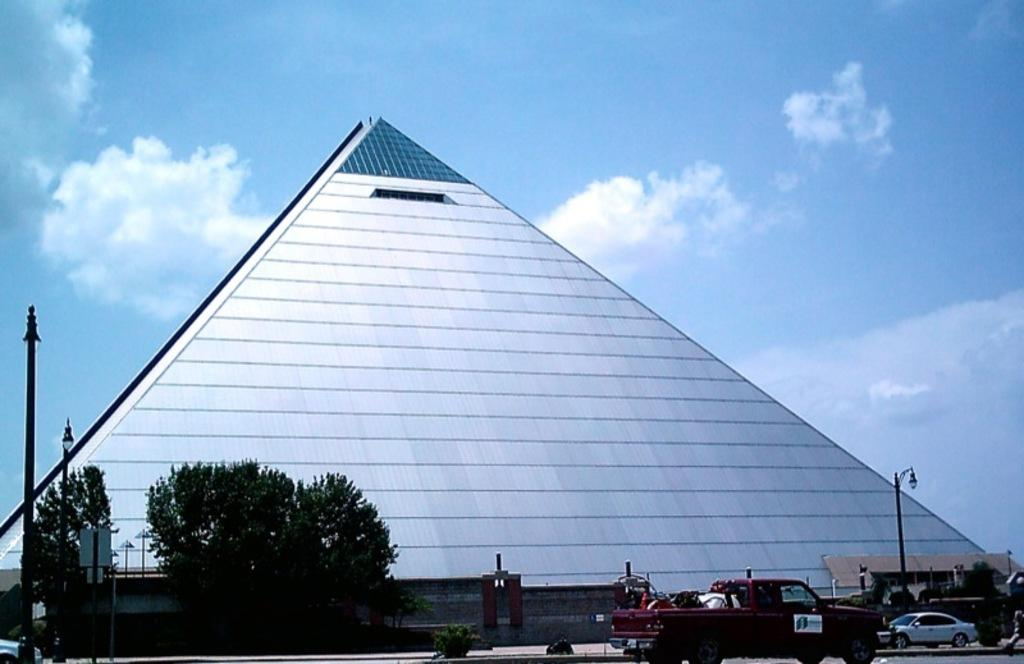What type of structure can be seen in the image? There is a building in the image. What natural elements are present in the image? There are trees in the image. What man-made objects can be seen in the image? Vehicles and poles are visible in the image. Can you describe the background of the image? The sky with clouds is visible in the background of the image. Are there any other objects in the image besides the building, trees, vehicles, and poles? Yes, there are other objects in the image. Can you tell me how many owls are perched on the power lines in the image? There are no owls or power lines present in the image. What type of board is being used by the people in the image? There are no people or boards present in the image. 